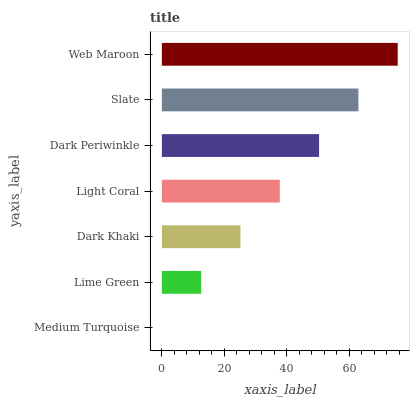Is Medium Turquoise the minimum?
Answer yes or no. Yes. Is Web Maroon the maximum?
Answer yes or no. Yes. Is Lime Green the minimum?
Answer yes or no. No. Is Lime Green the maximum?
Answer yes or no. No. Is Lime Green greater than Medium Turquoise?
Answer yes or no. Yes. Is Medium Turquoise less than Lime Green?
Answer yes or no. Yes. Is Medium Turquoise greater than Lime Green?
Answer yes or no. No. Is Lime Green less than Medium Turquoise?
Answer yes or no. No. Is Light Coral the high median?
Answer yes or no. Yes. Is Light Coral the low median?
Answer yes or no. Yes. Is Dark Khaki the high median?
Answer yes or no. No. Is Dark Periwinkle the low median?
Answer yes or no. No. 